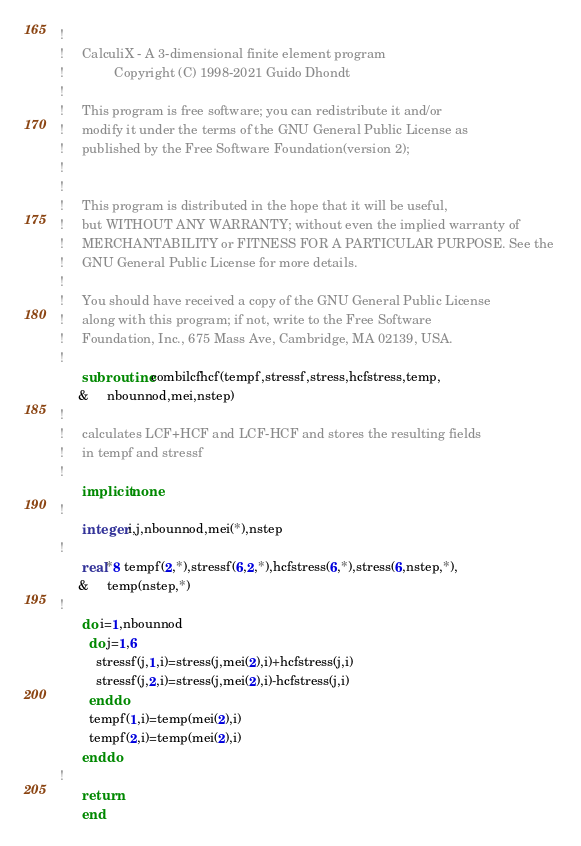<code> <loc_0><loc_0><loc_500><loc_500><_FORTRAN_>!
!     CalculiX - A 3-dimensional finite element program
!              Copyright (C) 1998-2021 Guido Dhondt
!
!     This program is free software; you can redistribute it and/or
!     modify it under the terms of the GNU General Public License as
!     published by the Free Software Foundation(version 2);
!     
!
!     This program is distributed in the hope that it will be useful,
!     but WITHOUT ANY WARRANTY; without even the implied warranty of 
!     MERCHANTABILITY or FITNESS FOR A PARTICULAR PURPOSE. See the 
!     GNU General Public License for more details.
!
!     You should have received a copy of the GNU General Public License
!     along with this program; if not, write to the Free Software
!     Foundation, Inc., 675 Mass Ave, Cambridge, MA 02139, USA.
!
      subroutine combilcfhcf(tempf,stressf,stress,hcfstress,temp,
     &     nbounnod,mei,nstep)
!
!     calculates LCF+HCF and LCF-HCF and stores the resulting fields
!     in tempf and stressf
!
      implicit none
!
      integer i,j,nbounnod,mei(*),nstep
!
      real*8 tempf(2,*),stressf(6,2,*),hcfstress(6,*),stress(6,nstep,*),
     &     temp(nstep,*)
!
      do i=1,nbounnod
        do j=1,6
          stressf(j,1,i)=stress(j,mei(2),i)+hcfstress(j,i)
          stressf(j,2,i)=stress(j,mei(2),i)-hcfstress(j,i)
        enddo
        tempf(1,i)=temp(mei(2),i)
        tempf(2,i)=temp(mei(2),i)
      enddo
!
      return
      end

</code> 